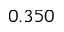<formula> <loc_0><loc_0><loc_500><loc_500>0 . 3 5 0</formula> 